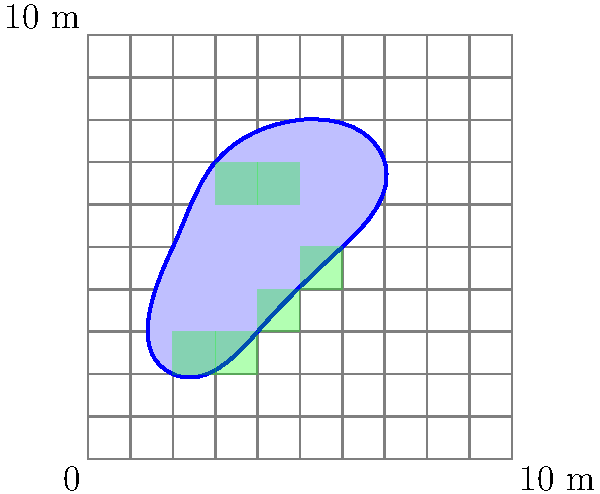A drug trial site has an irregular shape as shown in the diagram. Each square in the grid represents a 1m x 1m area. Using the grid method, estimate the area of the drug trial site to the nearest square meter. How would you improve this estimation using your programming skills? To estimate the area using the grid method:

1. Count the number of complete squares within the shape:
   There are 6 complete squares (shaded in green).

2. Count the number of partial squares:
   There are approximately 14 partial squares.

3. Estimate the area of partial squares:
   Assume each partial square is about half a complete square.
   Estimated partial area = 14 * 0.5 = 7 square meters

4. Calculate the total estimated area:
   Total area = Complete squares + Estimated partial squares
               = 6 + 7 = 13 square meters

To improve this estimation using programming skills:

1. Implement a more precise grid overlay with smaller squares (e.g., 0.1m x 0.1m).
2. Develop an algorithm to detect the boundary of the shape.
3. Use numerical integration techniques like the trapezoidal rule or Simpson's rule to calculate the area under the curve more accurately.
4. Implement a Monte Carlo method to estimate the area by generating random points and calculating the ratio of points inside the shape to total points.
5. Create a tool that allows users to trace the outline of the site precisely and calculates the area using polygon area formulas.

These programming approaches would significantly increase the accuracy of the area calculation compared to the manual grid method.
Answer: 13 square meters (estimated). Improve by implementing smaller grid, boundary detection, numerical integration, Monte Carlo method, or precise outline tracing tool. 